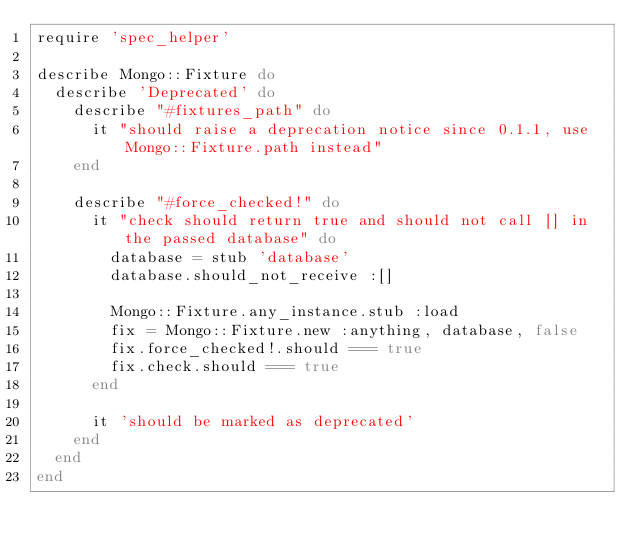<code> <loc_0><loc_0><loc_500><loc_500><_Ruby_>require 'spec_helper'

describe Mongo::Fixture do 
  describe 'Deprecated' do
    describe "#fixtures_path" do
      it "should raise a deprecation notice since 0.1.1, use Mongo::Fixture.path instead"
    end

    describe "#force_checked!" do
      it "check should return true and should not call [] in the passed database" do
        database = stub 'database'
        database.should_not_receive :[]
        
        Mongo::Fixture.any_instance.stub :load
        fix = Mongo::Fixture.new :anything, database, false
        fix.force_checked!.should === true
        fix.check.should === true
      end

      it 'should be marked as deprecated' 
    end
  end
end</code> 